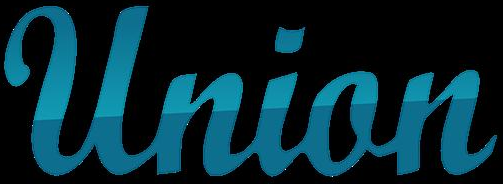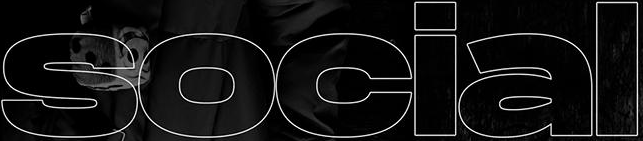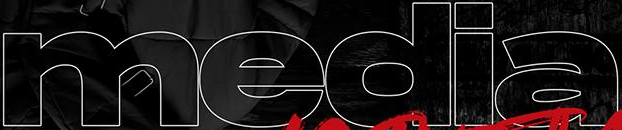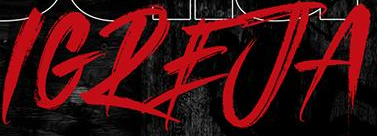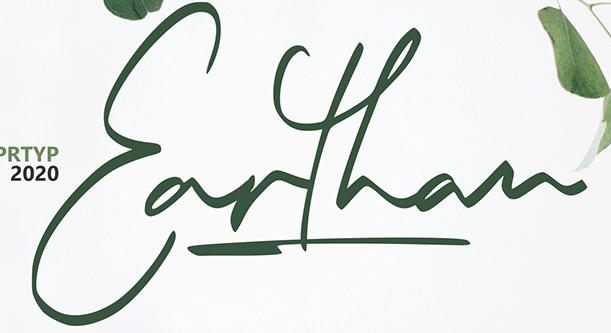Identify the words shown in these images in order, separated by a semicolon. Union; social; media; IGREJA; Earthan 